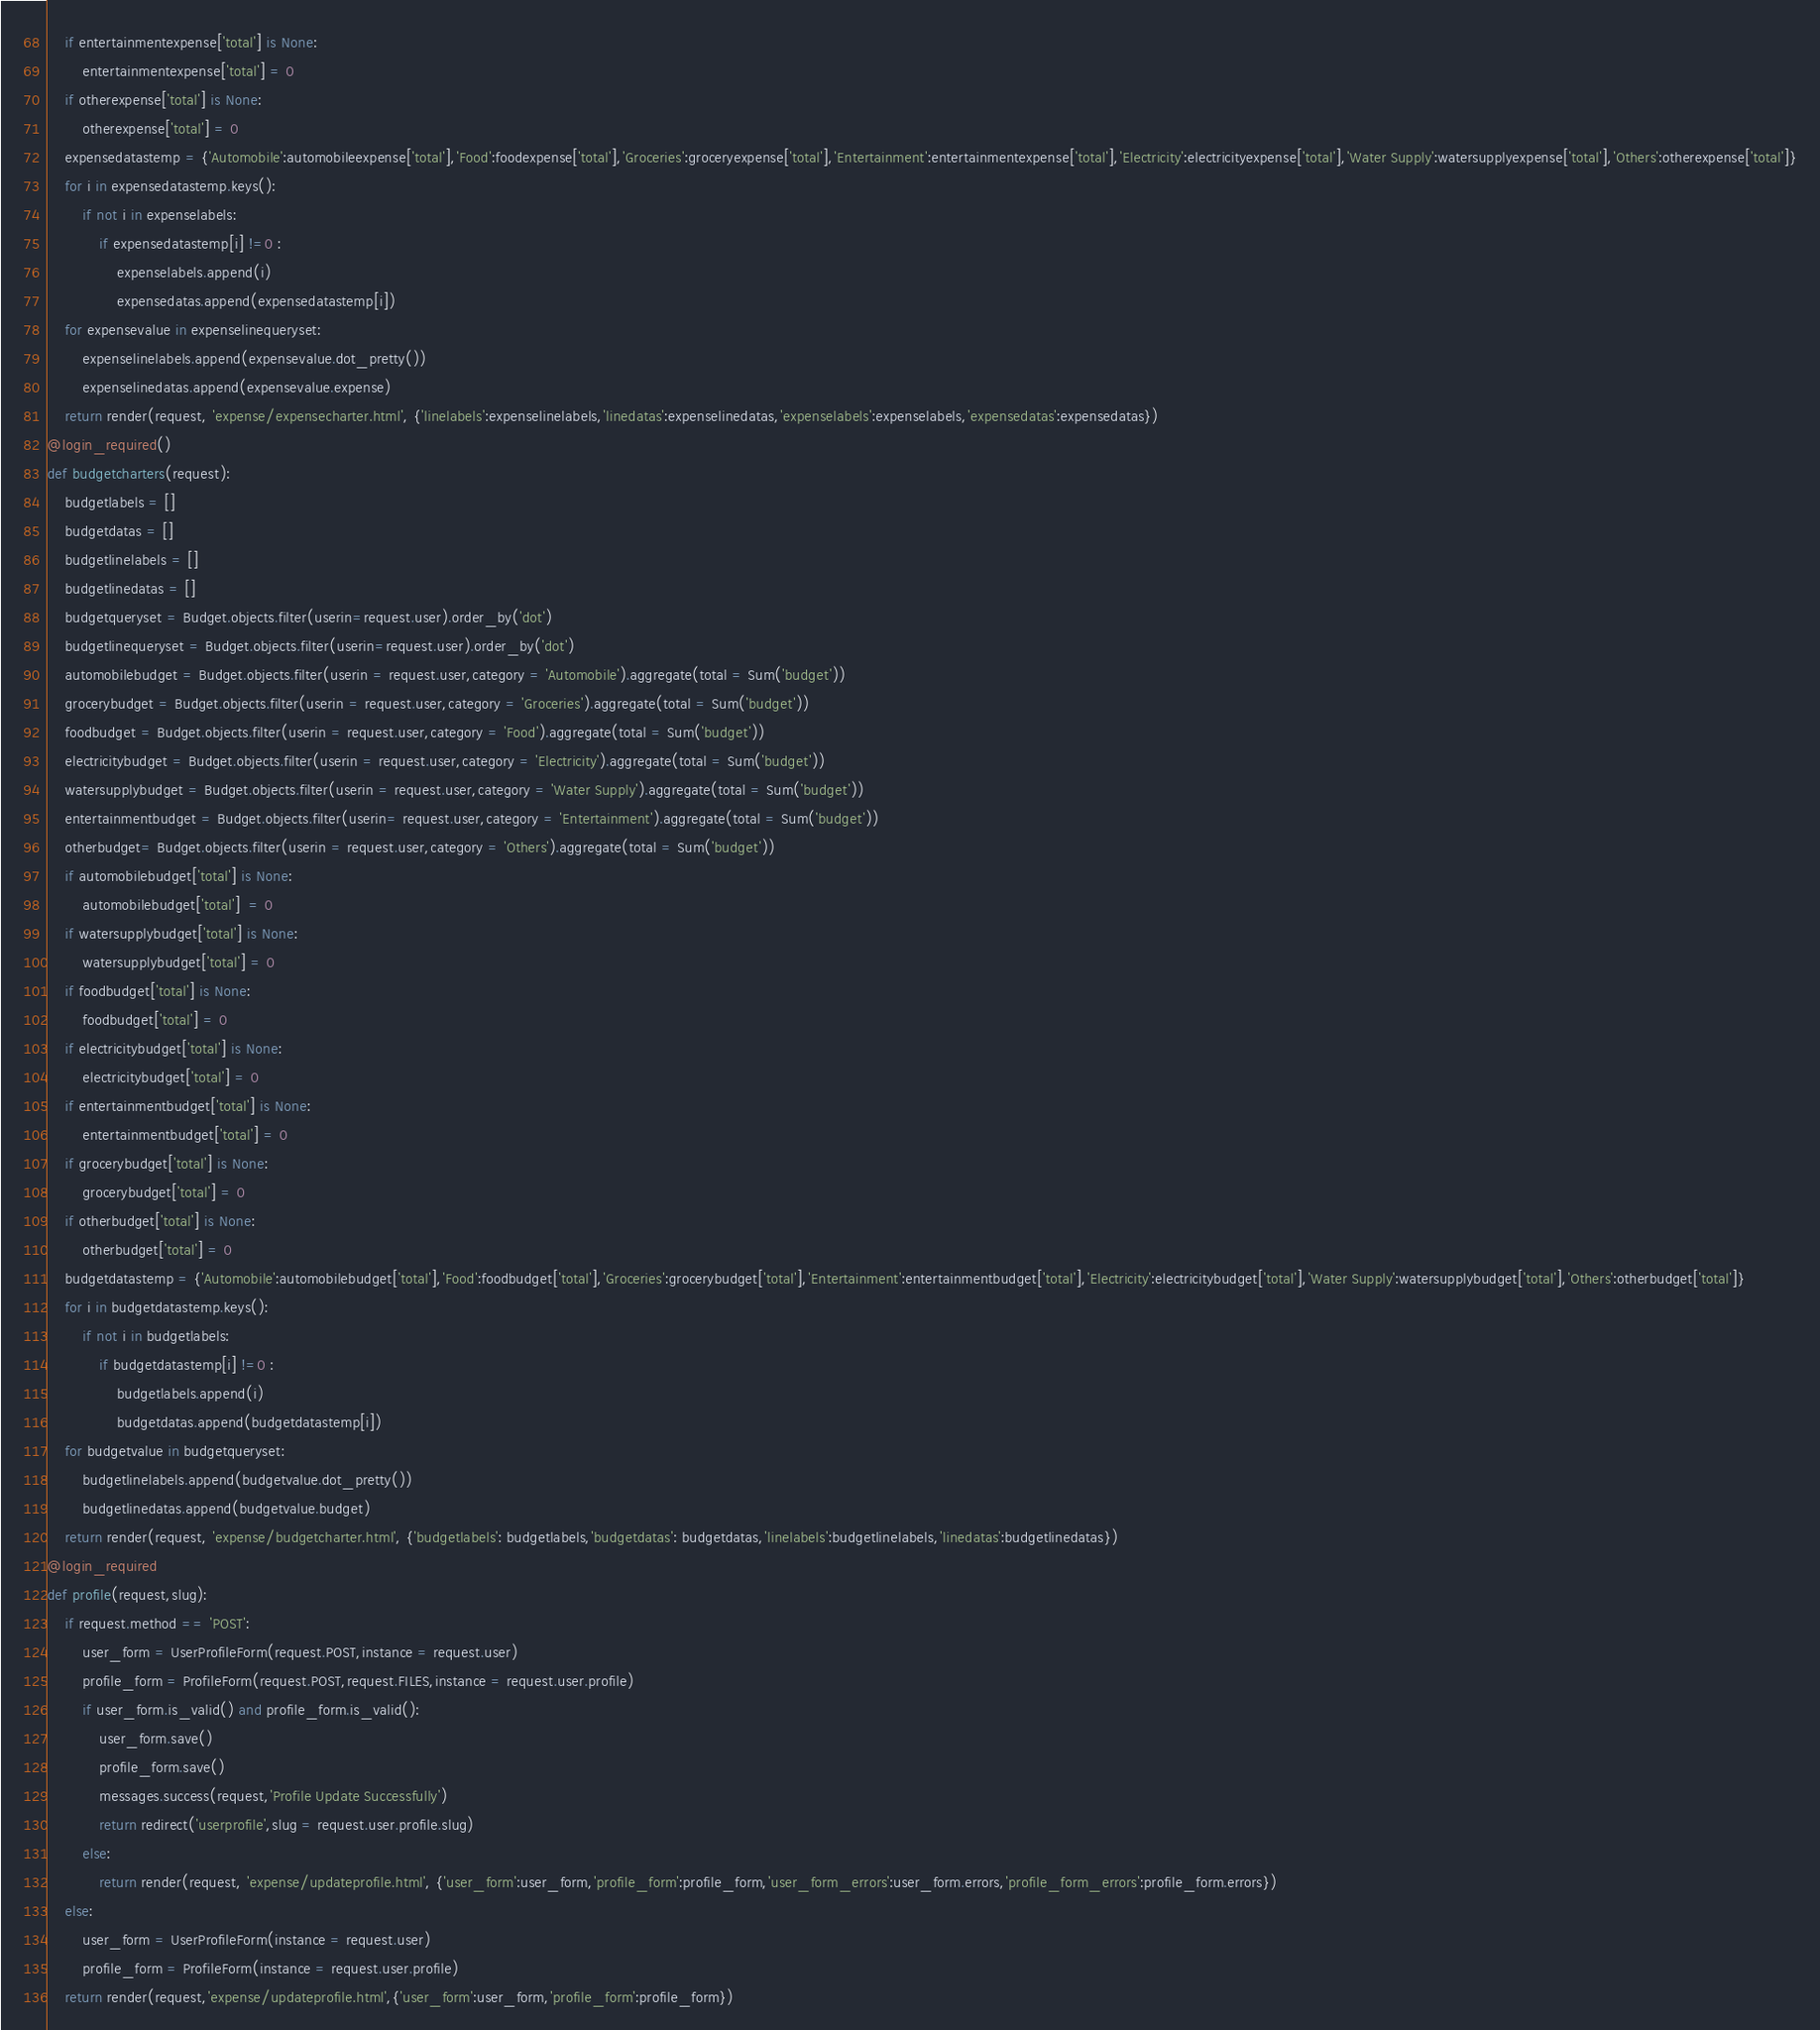<code> <loc_0><loc_0><loc_500><loc_500><_Python_>    if entertainmentexpense['total'] is None:
        entertainmentexpense['total'] = 0
    if otherexpense['total'] is None:
        otherexpense['total'] = 0
    expensedatastemp = {'Automobile':automobileexpense['total'],'Food':foodexpense['total'],'Groceries':groceryexpense['total'],'Entertainment':entertainmentexpense['total'],'Electricity':electricityexpense['total'],'Water Supply':watersupplyexpense['total'],'Others':otherexpense['total']}
    for i in expensedatastemp.keys():
        if not i in expenselabels:
            if expensedatastemp[i] !=0 :
                expenselabels.append(i)
                expensedatas.append(expensedatastemp[i])
    for expensevalue in expenselinequeryset:
        expenselinelabels.append(expensevalue.dot_pretty())
        expenselinedatas.append(expensevalue.expense)
    return render(request, 'expense/expensecharter.html', {'linelabels':expenselinelabels,'linedatas':expenselinedatas,'expenselabels':expenselabels,'expensedatas':expensedatas})
@login_required()
def budgetcharters(request):
    budgetlabels = []
    budgetdatas = []
    budgetlinelabels = []
    budgetlinedatas = []
    budgetqueryset = Budget.objects.filter(userin=request.user).order_by('dot')
    budgetlinequeryset = Budget.objects.filter(userin=request.user).order_by('dot')
    automobilebudget = Budget.objects.filter(userin = request.user,category = 'Automobile').aggregate(total = Sum('budget'))
    grocerybudget = Budget.objects.filter(userin = request.user,category = 'Groceries').aggregate(total = Sum('budget'))
    foodbudget = Budget.objects.filter(userin = request.user,category = 'Food').aggregate(total = Sum('budget'))
    electricitybudget = Budget.objects.filter(userin = request.user,category = 'Electricity').aggregate(total = Sum('budget'))
    watersupplybudget = Budget.objects.filter(userin = request.user,category = 'Water Supply').aggregate(total = Sum('budget'))
    entertainmentbudget = Budget.objects.filter(userin= request.user,category = 'Entertainment').aggregate(total = Sum('budget'))
    otherbudget= Budget.objects.filter(userin = request.user,category = 'Others').aggregate(total = Sum('budget'))
    if automobilebudget['total'] is None:
        automobilebudget['total']  = 0
    if watersupplybudget['total'] is None:
        watersupplybudget['total'] = 0
    if foodbudget['total'] is None:
        foodbudget['total'] = 0
    if electricitybudget['total'] is None:
        electricitybudget['total'] = 0
    if entertainmentbudget['total'] is None:
        entertainmentbudget['total'] = 0
    if grocerybudget['total'] is None:
        grocerybudget['total'] = 0
    if otherbudget['total'] is None:
        otherbudget['total'] = 0
    budgetdatastemp = {'Automobile':automobilebudget['total'],'Food':foodbudget['total'],'Groceries':grocerybudget['total'],'Entertainment':entertainmentbudget['total'],'Electricity':electricitybudget['total'],'Water Supply':watersupplybudget['total'],'Others':otherbudget['total']}
    for i in budgetdatastemp.keys():
        if not i in budgetlabels:
            if budgetdatastemp[i] !=0 :
                budgetlabels.append(i)
                budgetdatas.append(budgetdatastemp[i])
    for budgetvalue in budgetqueryset:
        budgetlinelabels.append(budgetvalue.dot_pretty())
        budgetlinedatas.append(budgetvalue.budget)
    return render(request, 'expense/budgetcharter.html', {'budgetlabels': budgetlabels,'budgetdatas': budgetdatas,'linelabels':budgetlinelabels,'linedatas':budgetlinedatas})
@login_required
def profile(request,slug):
    if request.method == 'POST':
        user_form = UserProfileForm(request.POST,instance = request.user)
        profile_form = ProfileForm(request.POST,request.FILES,instance = request.user.profile)
        if user_form.is_valid() and profile_form.is_valid():
            user_form.save()
            profile_form.save()
            messages.success(request,'Profile Update Successfully')
            return redirect('userprofile',slug = request.user.profile.slug)
        else:
            return render(request, 'expense/updateprofile.html', {'user_form':user_form,'profile_form':profile_form,'user_form_errors':user_form.errors,'profile_form_errors':profile_form.errors})
    else:
        user_form = UserProfileForm(instance = request.user)
        profile_form = ProfileForm(instance = request.user.profile)
    return render(request,'expense/updateprofile.html',{'user_form':user_form,'profile_form':profile_form})
</code> 